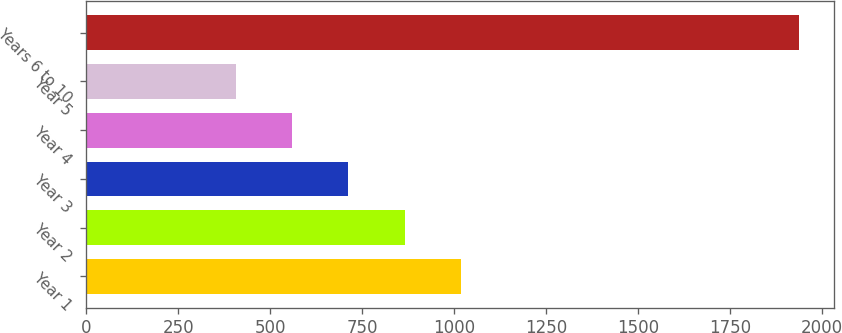<chart> <loc_0><loc_0><loc_500><loc_500><bar_chart><fcel>Year 1<fcel>Year 2<fcel>Year 3<fcel>Year 4<fcel>Year 5<fcel>Years 6 to 10<nl><fcel>1019<fcel>866<fcel>713<fcel>560<fcel>407<fcel>1937<nl></chart> 